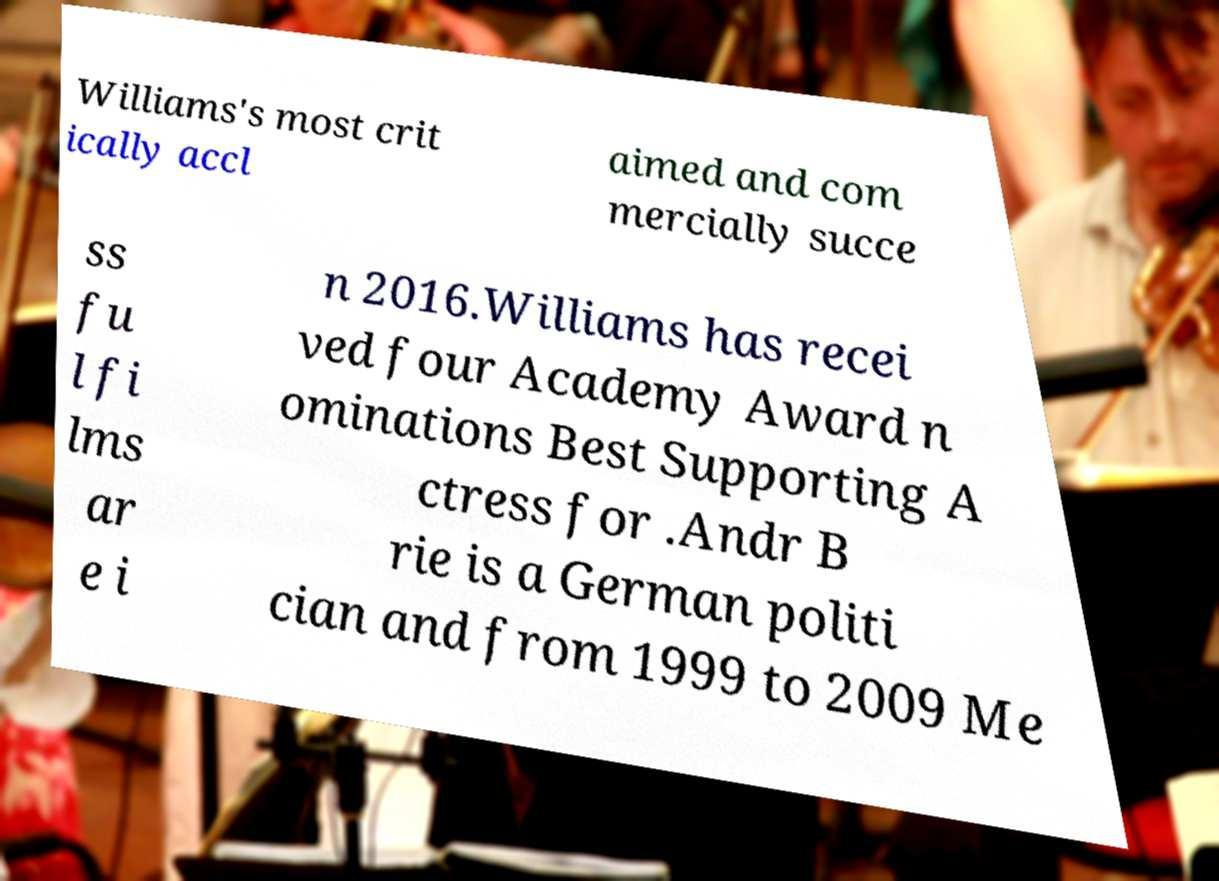Please read and relay the text visible in this image. What does it say? Williams's most crit ically accl aimed and com mercially succe ss fu l fi lms ar e i n 2016.Williams has recei ved four Academy Award n ominations Best Supporting A ctress for .Andr B rie is a German politi cian and from 1999 to 2009 Me 